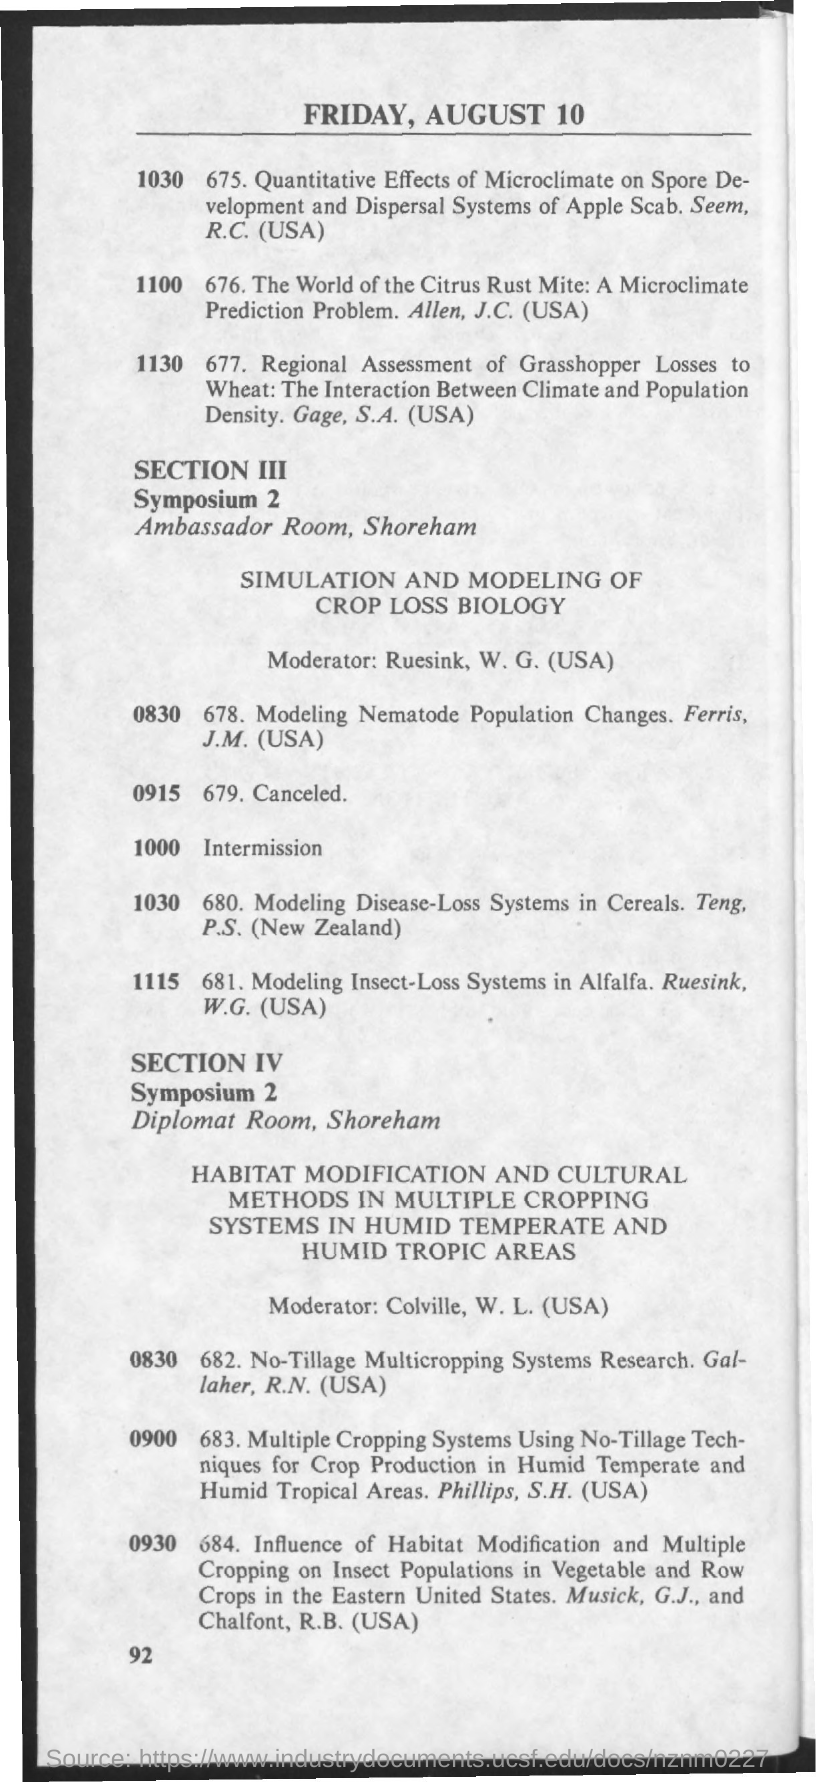What is the date mentioned in the given page ?
Offer a terse response. Friday, august 10. What is the name of the room for symposium 2 , section 3?
Your response must be concise. Ambassador room. What is the name of the room for symposium 2,section 4 ?
Provide a short and direct response. Diplomat room. What is the name of the moderator mentioned in section 3 ?
Your answer should be very brief. Ruesink, w.g. (usa). What is the name of the moderator mentioned in section 4?
Offer a terse response. COLVILLE, W.L. (USA). 